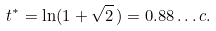<formula> <loc_0><loc_0><loc_500><loc_500>t ^ { * } = \ln ( 1 + \sqrt { 2 } \, ) = 0 . 8 8 \dots c .</formula> 